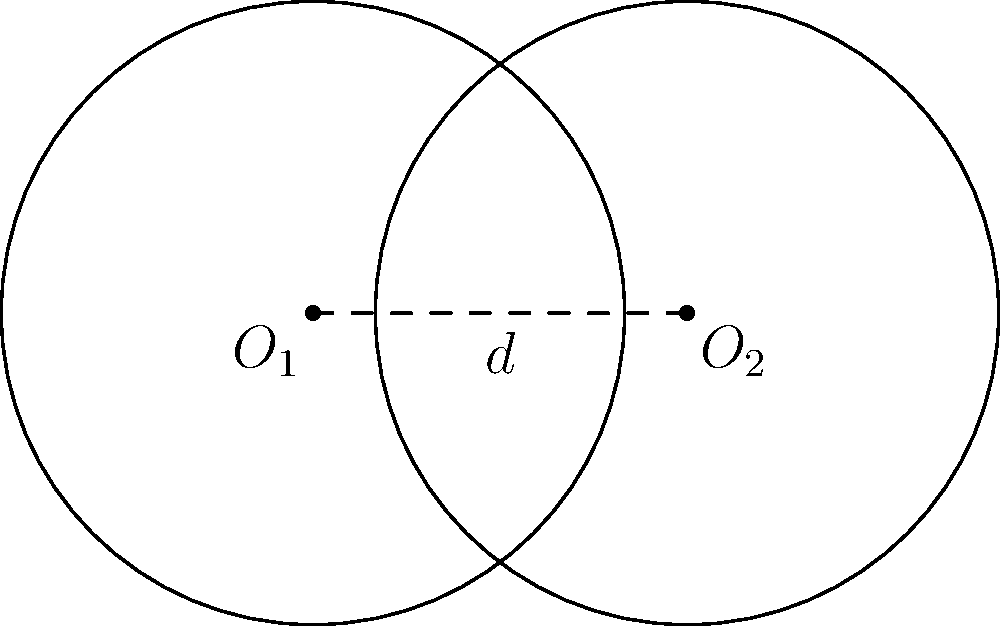In a tabletop game, two circular player zones are represented on the game mat. Each circle has a radius of 2.5 units, and their centers are 3 units apart. As a commentator, you need to quickly determine the area of the overlapping region between these two zones. What is the area of overlap? To find the area of overlap between two circles, we can follow these steps:

1) First, we need to determine if the circles intersect. The distance between centers (d) is 3, which is less than the sum of the radii (2.5 + 2.5 = 5), so they do intersect.

2) The formula for the area of overlap is:

   $$A = 2r^2 \arccos(\frac{d}{2r}) - d\sqrt{r^2 - (\frac{d}{2})^2}$$

   Where $r$ is the radius and $d$ is the distance between centers.

3) Let's substitute our values:
   $r = 2.5$ and $d = 3$

4) Calculate $\frac{d}{2r}$:
   $$\frac{d}{2r} = \frac{3}{2(2.5)} = 0.6$$

5) Calculate $\arccos(0.6)$:
   $$\arccos(0.6) \approx 0.9273 \text{ radians}$$

6) Calculate $\sqrt{r^2 - (\frac{d}{2})^2}$:
   $$\sqrt{2.5^2 - (\frac{3}{2})^2} = \sqrt{6.25 - 2.25} = \sqrt{4} = 2$$

7) Now, let's put it all together:
   $$A = 2(2.5)^2(0.9273) - 3(2)$$
   $$A = 2(6.25)(0.9273) - 6$$
   $$A = 11.59125 - 6$$
   $$A = 5.59125 \text{ square units}$$

8) Rounding to two decimal places:
   $$A \approx 5.59 \text{ square units}$$
Answer: 5.59 square units 